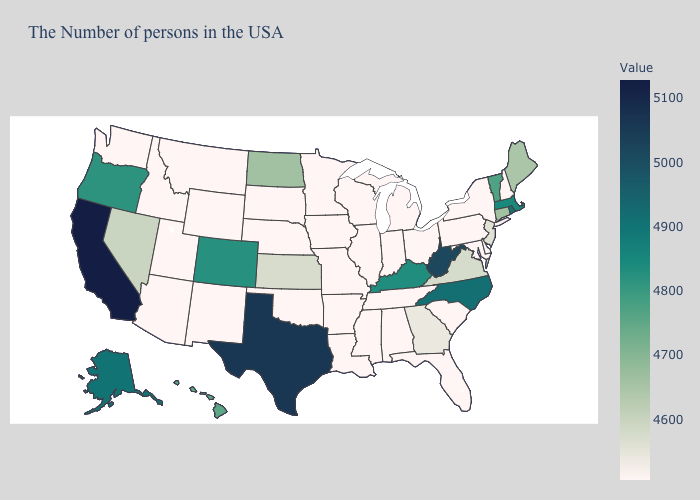Does the map have missing data?
Short answer required. No. Among the states that border Louisiana , which have the lowest value?
Quick response, please. Mississippi, Arkansas. Which states have the highest value in the USA?
Be succinct. California. Among the states that border Ohio , which have the lowest value?
Write a very short answer. Pennsylvania, Michigan, Indiana. Which states have the highest value in the USA?
Answer briefly. California. Which states have the lowest value in the USA?
Quick response, please. New Hampshire, New York, Delaware, Maryland, Pennsylvania, South Carolina, Ohio, Florida, Michigan, Indiana, Alabama, Tennessee, Wisconsin, Illinois, Mississippi, Louisiana, Missouri, Arkansas, Minnesota, Iowa, Nebraska, Oklahoma, South Dakota, Wyoming, New Mexico, Utah, Montana, Arizona, Idaho, Washington. 